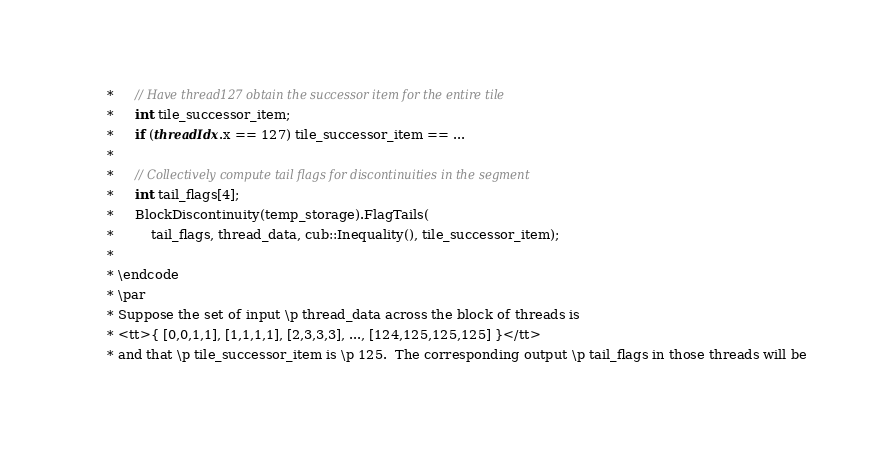Convert code to text. <code><loc_0><loc_0><loc_500><loc_500><_Cuda_>     *     // Have thread127 obtain the successor item for the entire tile
     *     int tile_successor_item;
     *     if (threadIdx.x == 127) tile_successor_item == ...
     *
     *     // Collectively compute tail flags for discontinuities in the segment
     *     int tail_flags[4];
     *     BlockDiscontinuity(temp_storage).FlagTails(
     *         tail_flags, thread_data, cub::Inequality(), tile_successor_item);
     *
     * \endcode
     * \par
     * Suppose the set of input \p thread_data across the block of threads is
     * <tt>{ [0,0,1,1], [1,1,1,1], [2,3,3,3], ..., [124,125,125,125] }</tt>
     * and that \p tile_successor_item is \p 125.  The corresponding output \p tail_flags in those threads will be</code> 